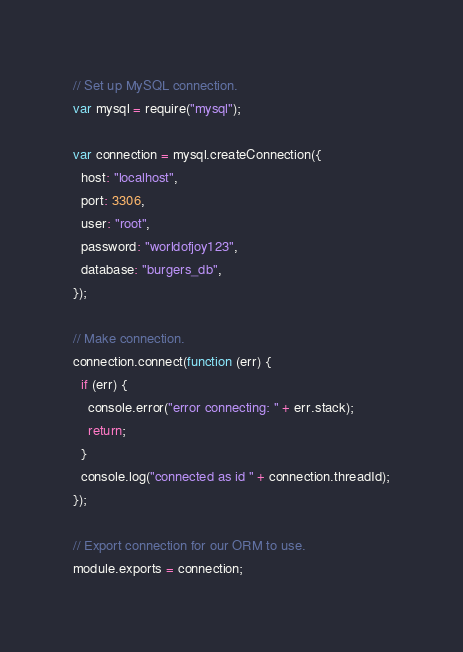<code> <loc_0><loc_0><loc_500><loc_500><_JavaScript_>// Set up MySQL connection.
var mysql = require("mysql");

var connection = mysql.createConnection({
  host: "localhost",
  port: 3306,
  user: "root",
  password: "worldofjoy123",
  database: "burgers_db",
});

// Make connection.
connection.connect(function (err) {
  if (err) {
    console.error("error connecting: " + err.stack);
    return;
  }
  console.log("connected as id " + connection.threadId);
});

// Export connection for our ORM to use.
module.exports = connection;</code> 